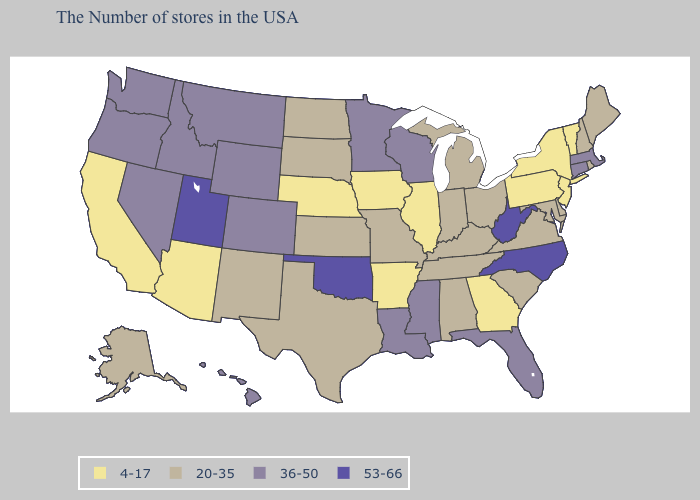What is the lowest value in the South?
Be succinct. 4-17. Does Wisconsin have the highest value in the MidWest?
Quick response, please. Yes. Which states have the highest value in the USA?
Keep it brief. North Carolina, West Virginia, Oklahoma, Utah. Among the states that border Montana , does Wyoming have the highest value?
Be succinct. Yes. Which states have the highest value in the USA?
Short answer required. North Carolina, West Virginia, Oklahoma, Utah. What is the value of North Dakota?
Quick response, please. 20-35. What is the lowest value in the West?
Write a very short answer. 4-17. What is the value of Oregon?
Give a very brief answer. 36-50. Does Iowa have a higher value than Colorado?
Write a very short answer. No. What is the value of Nebraska?
Give a very brief answer. 4-17. Among the states that border Illinois , which have the lowest value?
Keep it brief. Iowa. What is the value of Vermont?
Give a very brief answer. 4-17. What is the lowest value in the USA?
Quick response, please. 4-17. Does Minnesota have a higher value than Massachusetts?
Be succinct. No. What is the lowest value in states that border Washington?
Be succinct. 36-50. 